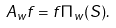Convert formula to latex. <formula><loc_0><loc_0><loc_500><loc_500>A _ { w } f = f \Pi _ { w } ( S ) .</formula> 